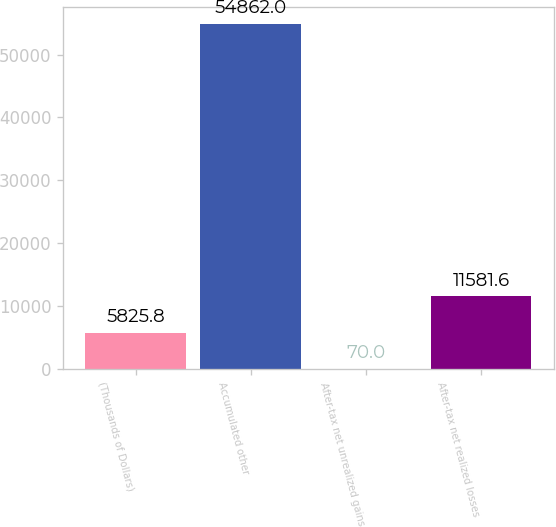<chart> <loc_0><loc_0><loc_500><loc_500><bar_chart><fcel>(Thousands of Dollars)<fcel>Accumulated other<fcel>After-tax net unrealized gains<fcel>After-tax net realized losses<nl><fcel>5825.8<fcel>54862<fcel>70<fcel>11581.6<nl></chart> 